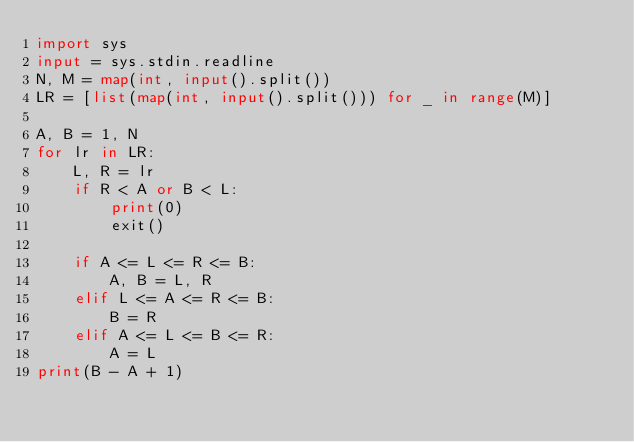<code> <loc_0><loc_0><loc_500><loc_500><_Python_>import sys
input = sys.stdin.readline
N, M = map(int, input().split())
LR = [list(map(int, input().split())) for _ in range(M)]

A, B = 1, N
for lr in LR:
    L, R = lr
    if R < A or B < L:
        print(0)
        exit()

    if A <= L <= R <= B:
        A, B = L, R
    elif L <= A <= R <= B:
        B = R
    elif A <= L <= B <= R:
        A = L
print(B - A + 1)
</code> 